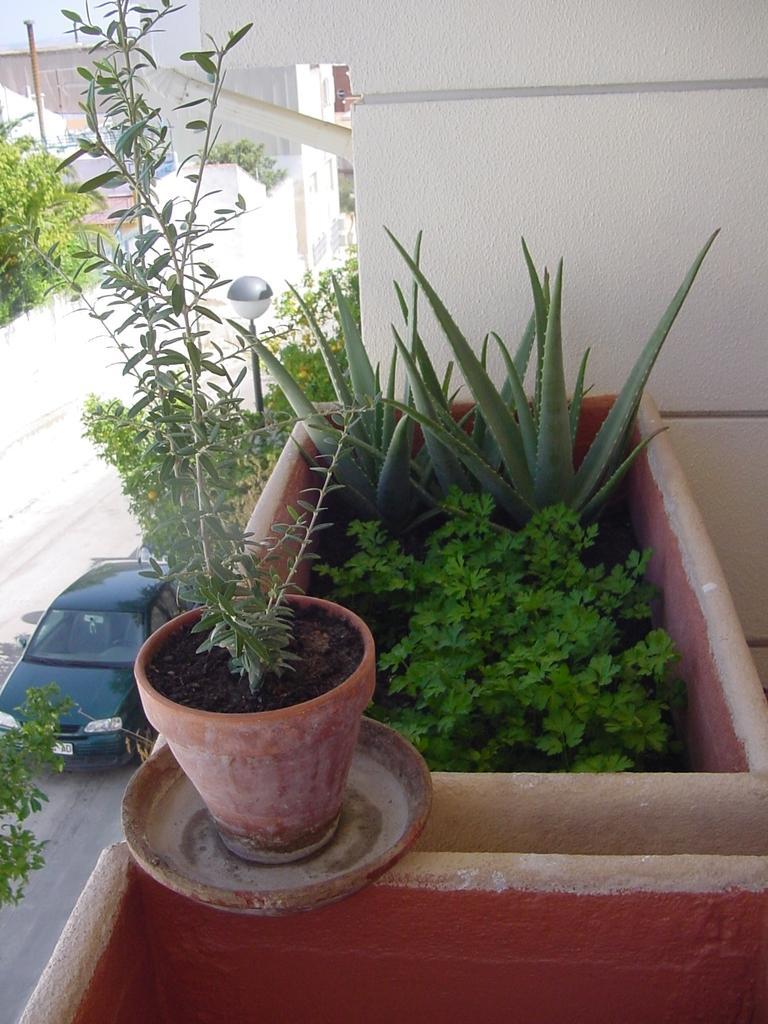In one or two sentences, can you explain what this image depicts? In the center of the image there are flower pots. In the background of the image there is wall. At the left side of the image there is a car. There is a road. 